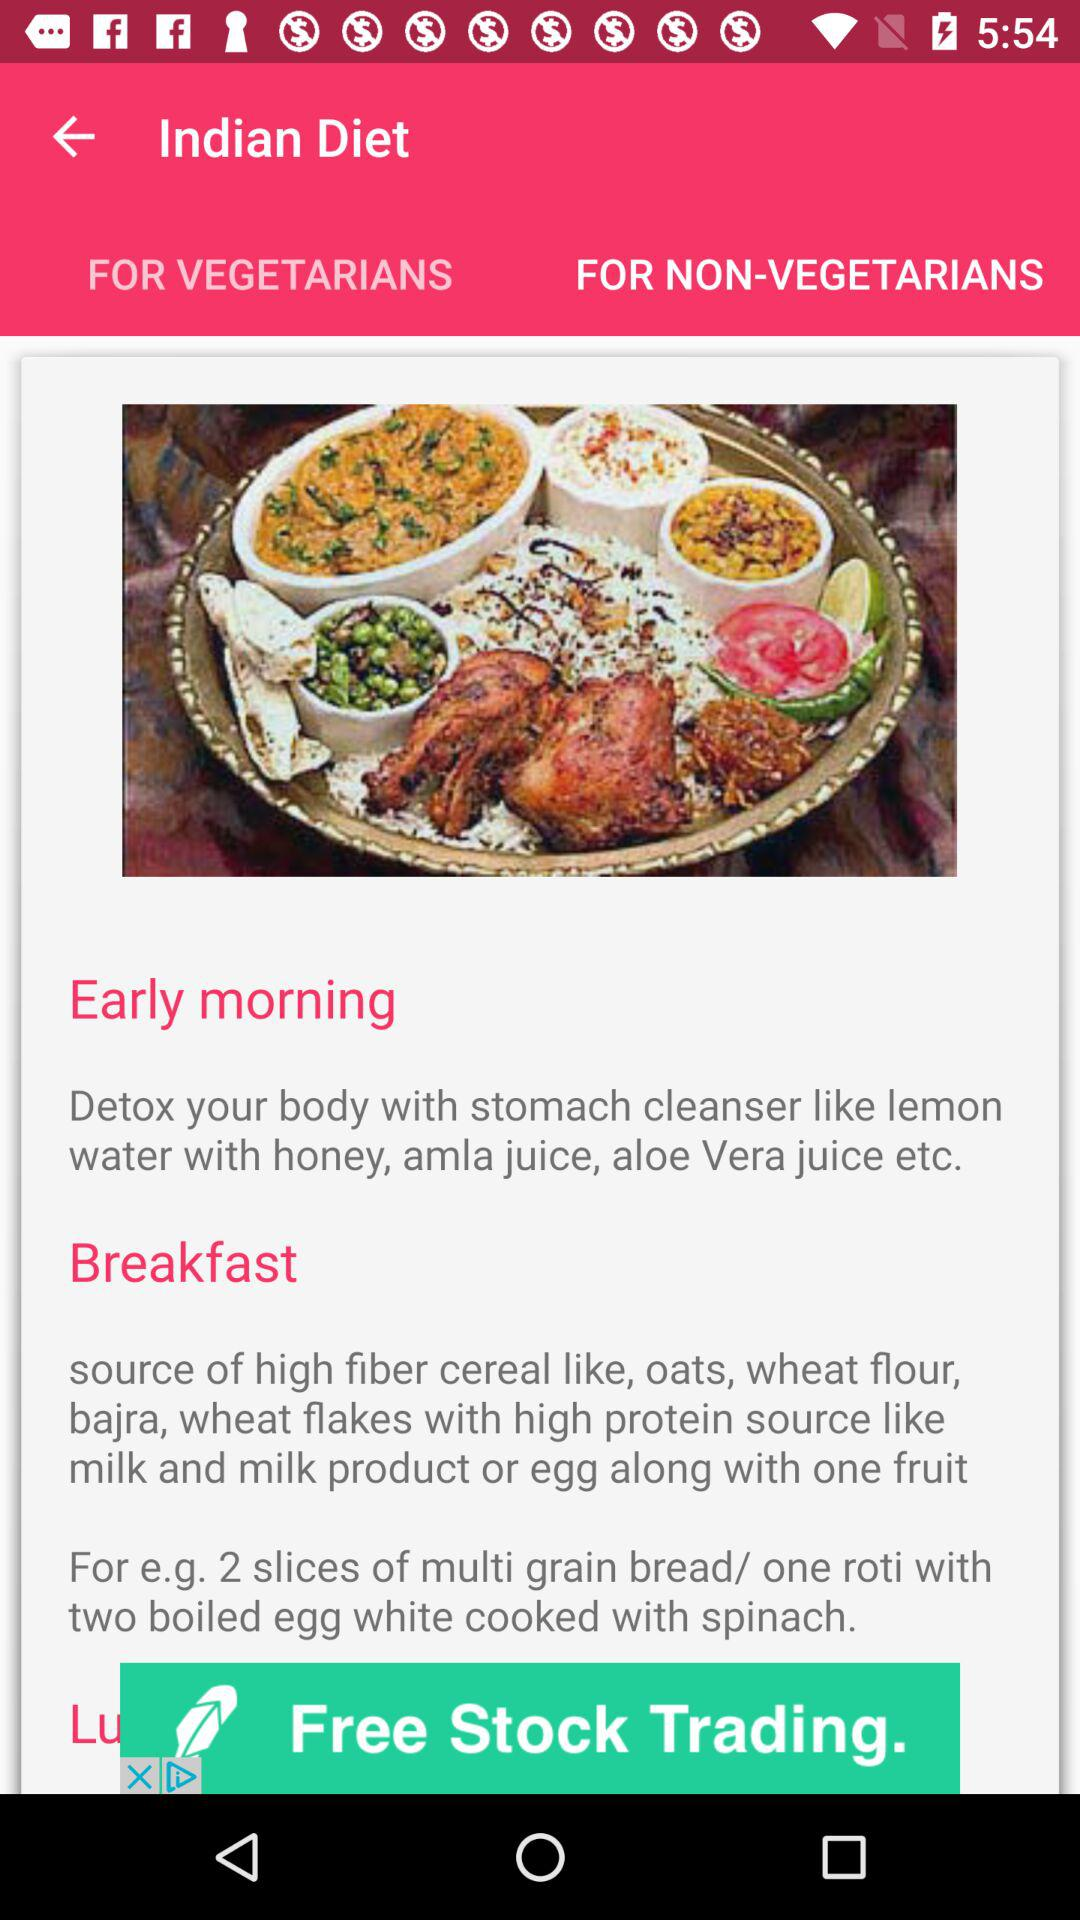What items help you with stomach cleansing? The items are lemon water with honey, amla juice, aloe vera juice, etc. 